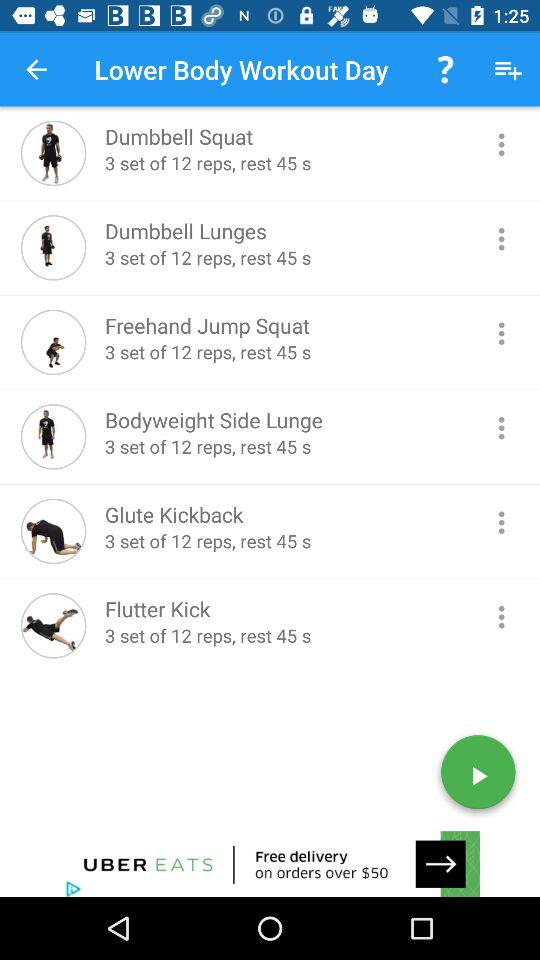How many exercises are there?
Answer the question using a single word or phrase. 6 